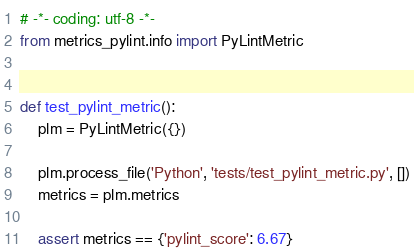Convert code to text. <code><loc_0><loc_0><loc_500><loc_500><_Python_># -*- coding: utf-8 -*-
from metrics_pylint.info import PyLintMetric


def test_pylint_metric():
    plm = PyLintMetric({})

    plm.process_file('Python', 'tests/test_pylint_metric.py', [])
    metrics = plm.metrics

    assert metrics == {'pylint_score': 6.67}
</code> 